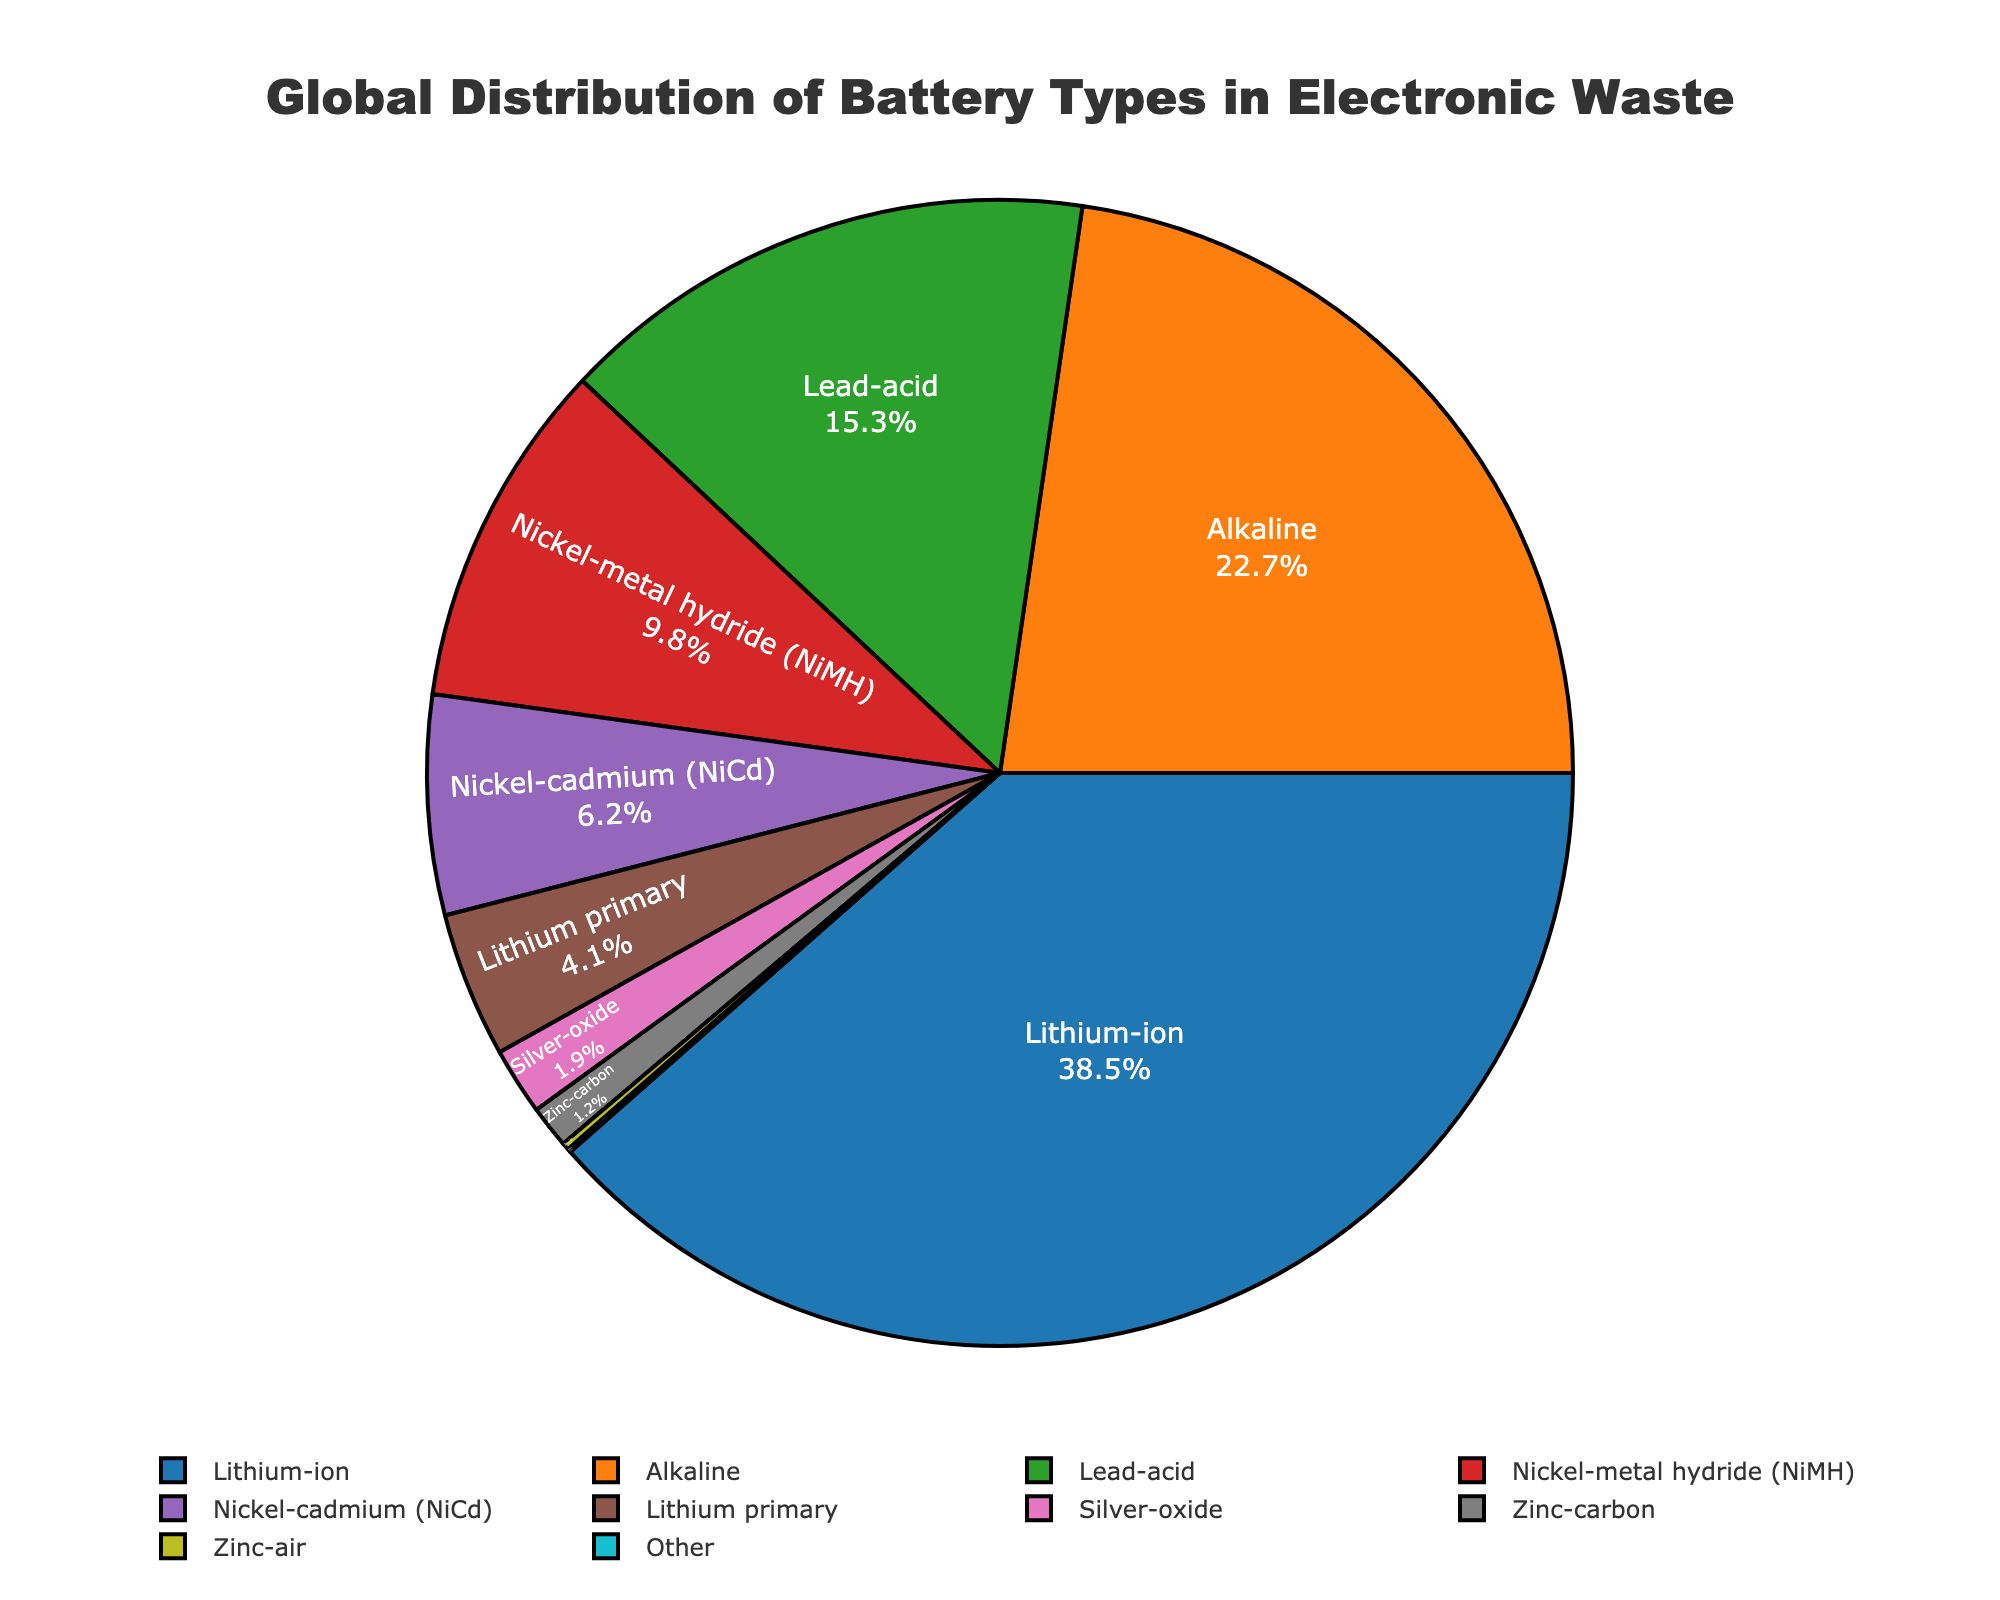What's the most common battery type in electronic waste? The pie chart shows the distribution of battery types. Lithium-ion has the largest percentage indicating it is the most common battery type.
Answer: Lithium-ion How much more common are Lithium-ion batteries compared to Zinc-air batteries? The pie chart shows that Lithium-ion batteries make up 38.5%, while Zinc-air makes up 0.2%. Subtract 0.2 from 38.5 to find the difference.
Answer: 38.3% What is the combined percentage of Lead-acid and Nickel-metal hydride batteries? To find the combined percentage, add the percentages of Lead-acid (15.3%) and Nickel-metal hydride (9.8%) batteries. 15.3 + 9.8 = 25.1%.
Answer: 25.1% Which two battery types together make up exactly half of the distribution shown? The chart shows Lithium-ion at 38.5% and Alkaline at 22.7%. Adding them gives 38.5 + 22.7 = 61.2%. No two types combine to exactly 50%. However, Lithium-ion and Lead-acid (15.3%) nearly approach half.
Answer: None Are there any battery types with similar percentages in the chart? Nickel-metal hydride (9.8%) and Nickel-cadmium (6.2%) have percentages that are comparatively close.
Answer: Nickel-metal hydride and Nickel-cadmium What percentage of electronic waste is made up of batteries that have less than 2% each? Silver-oxide (1.9%), Zinc-carbon (1.2%), Zinc-air (0.2%), and Other (0.1%) each have less than 2%. Add these percentages: 1.9 + 1.2 + 0.2 + 0.1 = 3.4%.
Answer: 3.4% How does the percentage of Alkaline batteries compare to that of Lead-acid batteries? Alkaline batteries make up 22.7%, while Lead-acid batteries make up 15.3%. 22.7% is greater than 15.3%.
Answer: Alkaline is greater than Lead-acid What is the percentage of batteries that are neither Lithium-ion nor Alkaline? Sum the percentages of all battery types except Lithium-ion (38.5%) and Alkaline (22.7%). 15.3 + 9.8 + 6.2 + 4.1 + 1.9 + 1.2 + 0.2 + 0.1 = 38.8%.
Answer: 38.8% Which battery type has the smallest share in electronic waste, and what is its percentage? The chart shows that 'Other' has the smallest share at 0.1%.
Answer: Other, 0.1% 